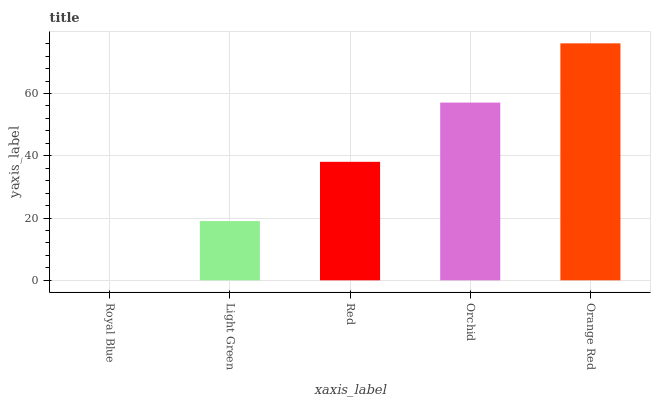Is Royal Blue the minimum?
Answer yes or no. Yes. Is Orange Red the maximum?
Answer yes or no. Yes. Is Light Green the minimum?
Answer yes or no. No. Is Light Green the maximum?
Answer yes or no. No. Is Light Green greater than Royal Blue?
Answer yes or no. Yes. Is Royal Blue less than Light Green?
Answer yes or no. Yes. Is Royal Blue greater than Light Green?
Answer yes or no. No. Is Light Green less than Royal Blue?
Answer yes or no. No. Is Red the high median?
Answer yes or no. Yes. Is Red the low median?
Answer yes or no. Yes. Is Light Green the high median?
Answer yes or no. No. Is Light Green the low median?
Answer yes or no. No. 